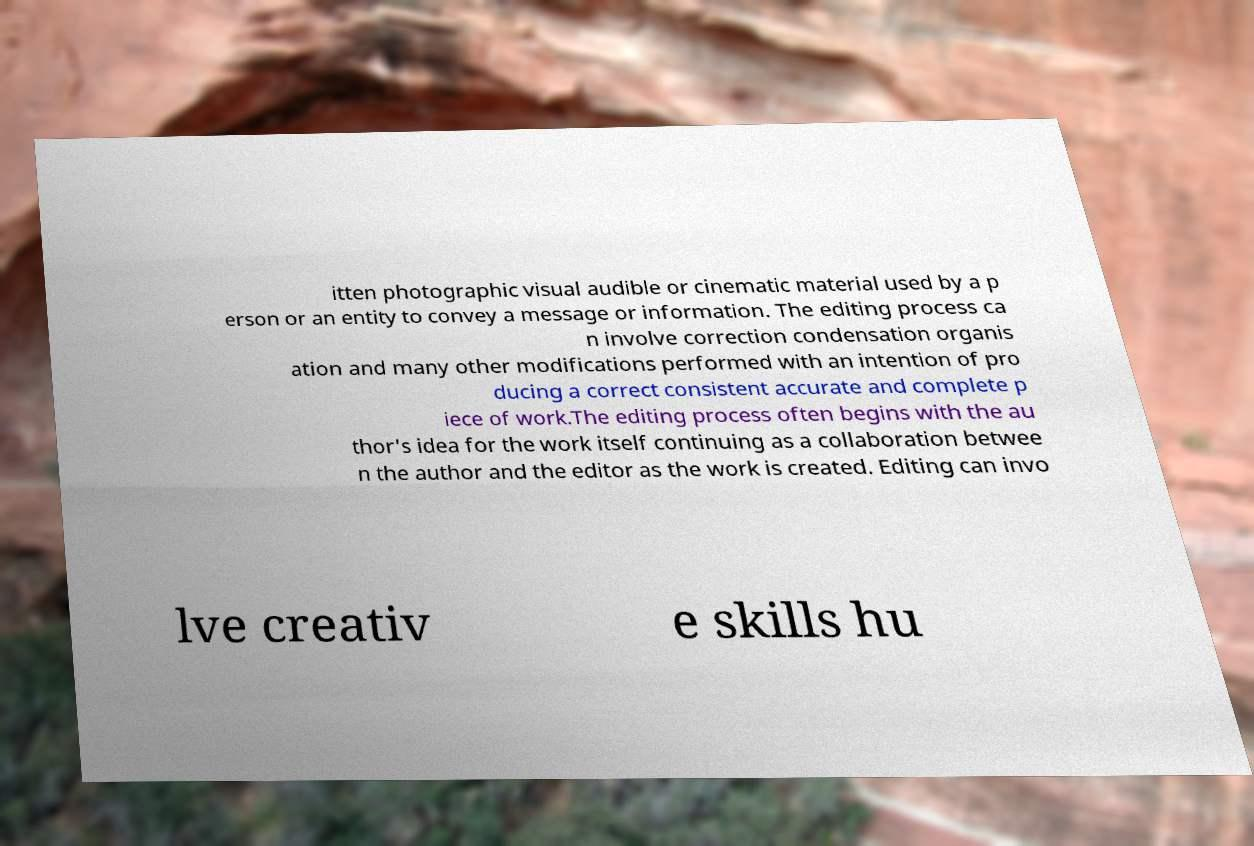Please identify and transcribe the text found in this image. itten photographic visual audible or cinematic material used by a p erson or an entity to convey a message or information. The editing process ca n involve correction condensation organis ation and many other modifications performed with an intention of pro ducing a correct consistent accurate and complete p iece of work.The editing process often begins with the au thor's idea for the work itself continuing as a collaboration betwee n the author and the editor as the work is created. Editing can invo lve creativ e skills hu 